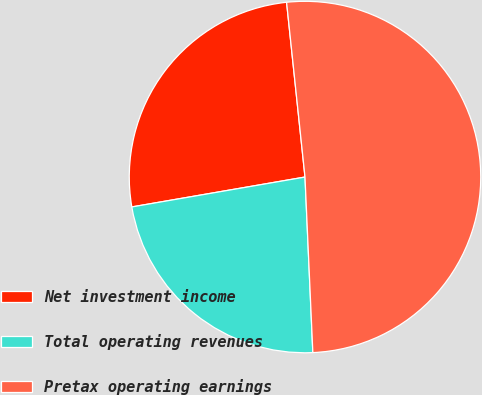Convert chart to OTSL. <chart><loc_0><loc_0><loc_500><loc_500><pie_chart><fcel>Net investment income<fcel>Total operating revenues<fcel>Pretax operating earnings<nl><fcel>26.05%<fcel>22.99%<fcel>50.96%<nl></chart> 